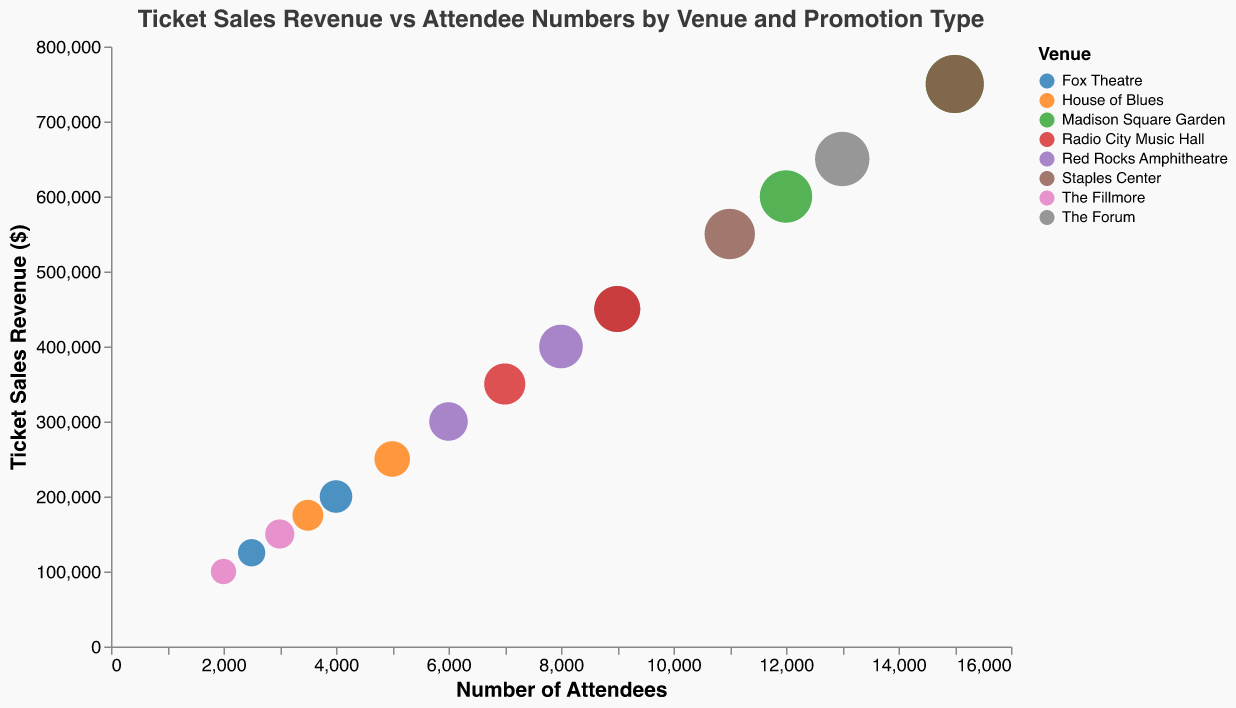What is the title of the chart? The title of the chart is displayed at the top and reads "Ticket Sales Revenue vs Attendee Numbers by Venue and Promotion Type".
Answer: Ticket Sales Revenue vs Attendee Numbers by Venue and Promotion Type How many venues are represented in the chart? There are different colored dots representing each venue. By counting the different colors in the legend, we can determine that there are 8 venues represented.
Answer: 8 What venue had the highest number of attendees and what promotion type was used? The largest circle in the chart represents the highest number of attendees. It corresponds to Madison Square Garden with Social Media promotion.
Answer: Madison Square Garden, Social Media Which promotion type is associated with the highest revenue at Staples Center? By looking at the dots representing Staples Center, we compare the y-axis values. The highest ticket sales revenue for Staples Center is associated with Social Media promotion.
Answer: Social Media Which venue had the lowest ticket sales revenue and what promotion type was used? The smallest y-axis value indicates the lowest revenue. The Fillmore with a Social Media promotion had the lowest ticket sales revenue.
Answer: The Fillmore, Social Media What is the difference in revenue between TV Advertisement and Radio Promotion at Radio City Music Hall? We locate the dots for Radio City Music Hall and compare the y-axis values for TV Advertisement ($350,000) and Radio Promotion ($450,000). The difference is $450,000 - $350,000 = $100,000.
Answer: $100,000 How many promotion types are used at Madison Square Garden and what are they? By identifying the shapes used for Madison Square Garden, we can count the different promotion types. There are two: Social Media and Email Campaign.
Answer: 2, Social Media and Email Campaign Which venue achieved exactly half the ticket sales revenue of $400,000 using Poster/Flyers promotion, and how many attendees were present? We look for the point representing Poster/Flyers with $200,000 revenue. This matches Fox Theatre with 2500 attendees.
Answer: Fox Theatre, 2500 Compare the number of attendees between Social Media promotion at Madison Square Garden and Staples Center. Which one had more attendees and by how many? We find the shapes for Social Media at both venues and compare the x-axis values. Madison Square Garden had 15,000 attendees and Staples Center also had 15,000 attendees, so they are equal.
Answer: Equal, 0 What is the average ticket sales revenue for all promotion types at Red Rocks Amphitheatre? Red Rocks Amphitheatre has two promotion types, Email Campaign ($400,000) and Poster/Flyers ($300,000). The average is ($400,000 + $300,000) / 2 = $350,000.
Answer: $350,000 